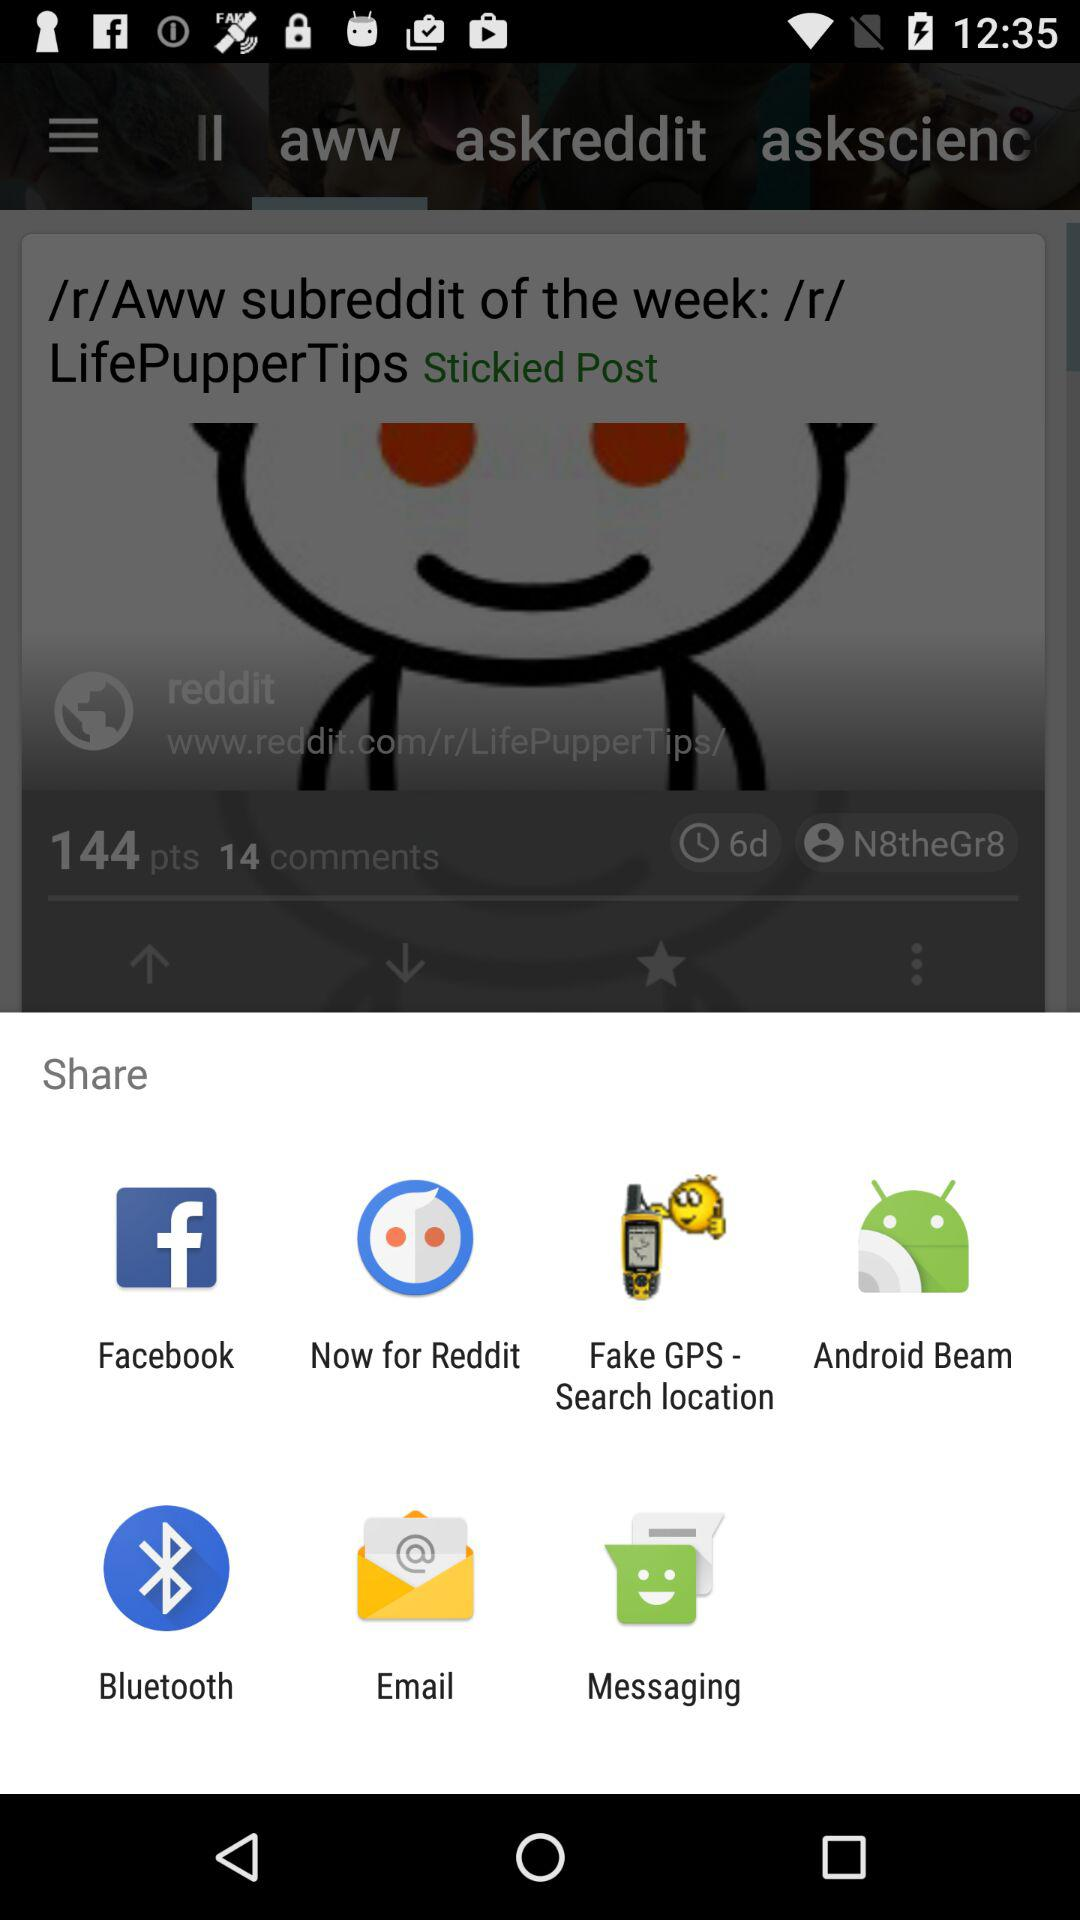Which application can I use to share? The applications are "Facebook", "Now for Reddit", "Fake GPS - Search location", "Android Beam", "Bluetooth", "Email" and "Messaging". 